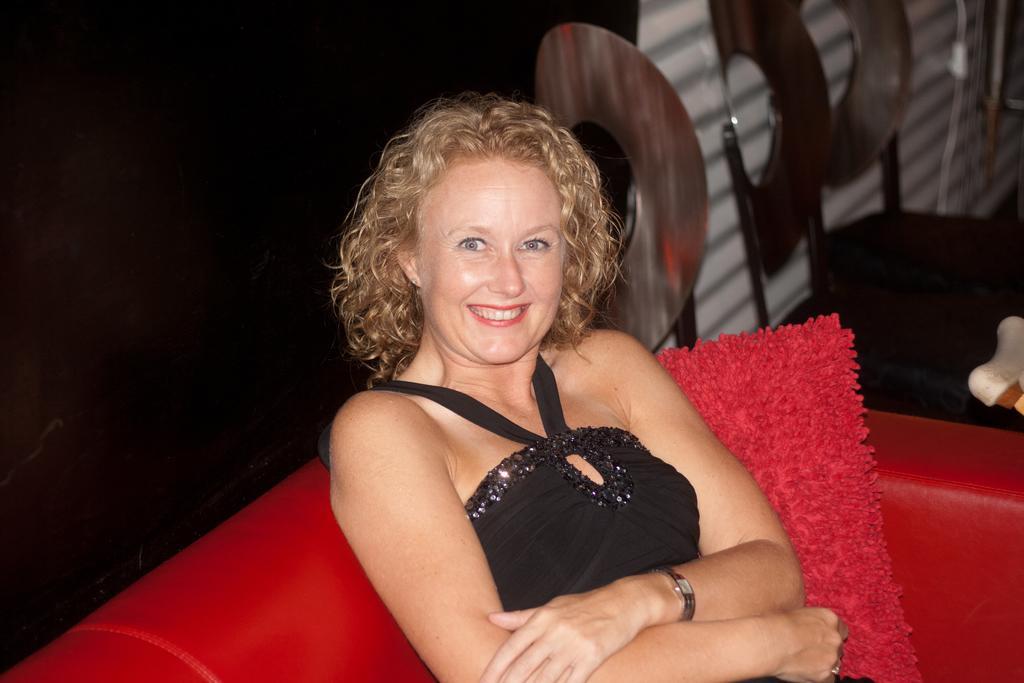Can you describe this image briefly? In this image there is a woman sitting in a sofa is having a smile on her face, beside the women there are empty chairs. 